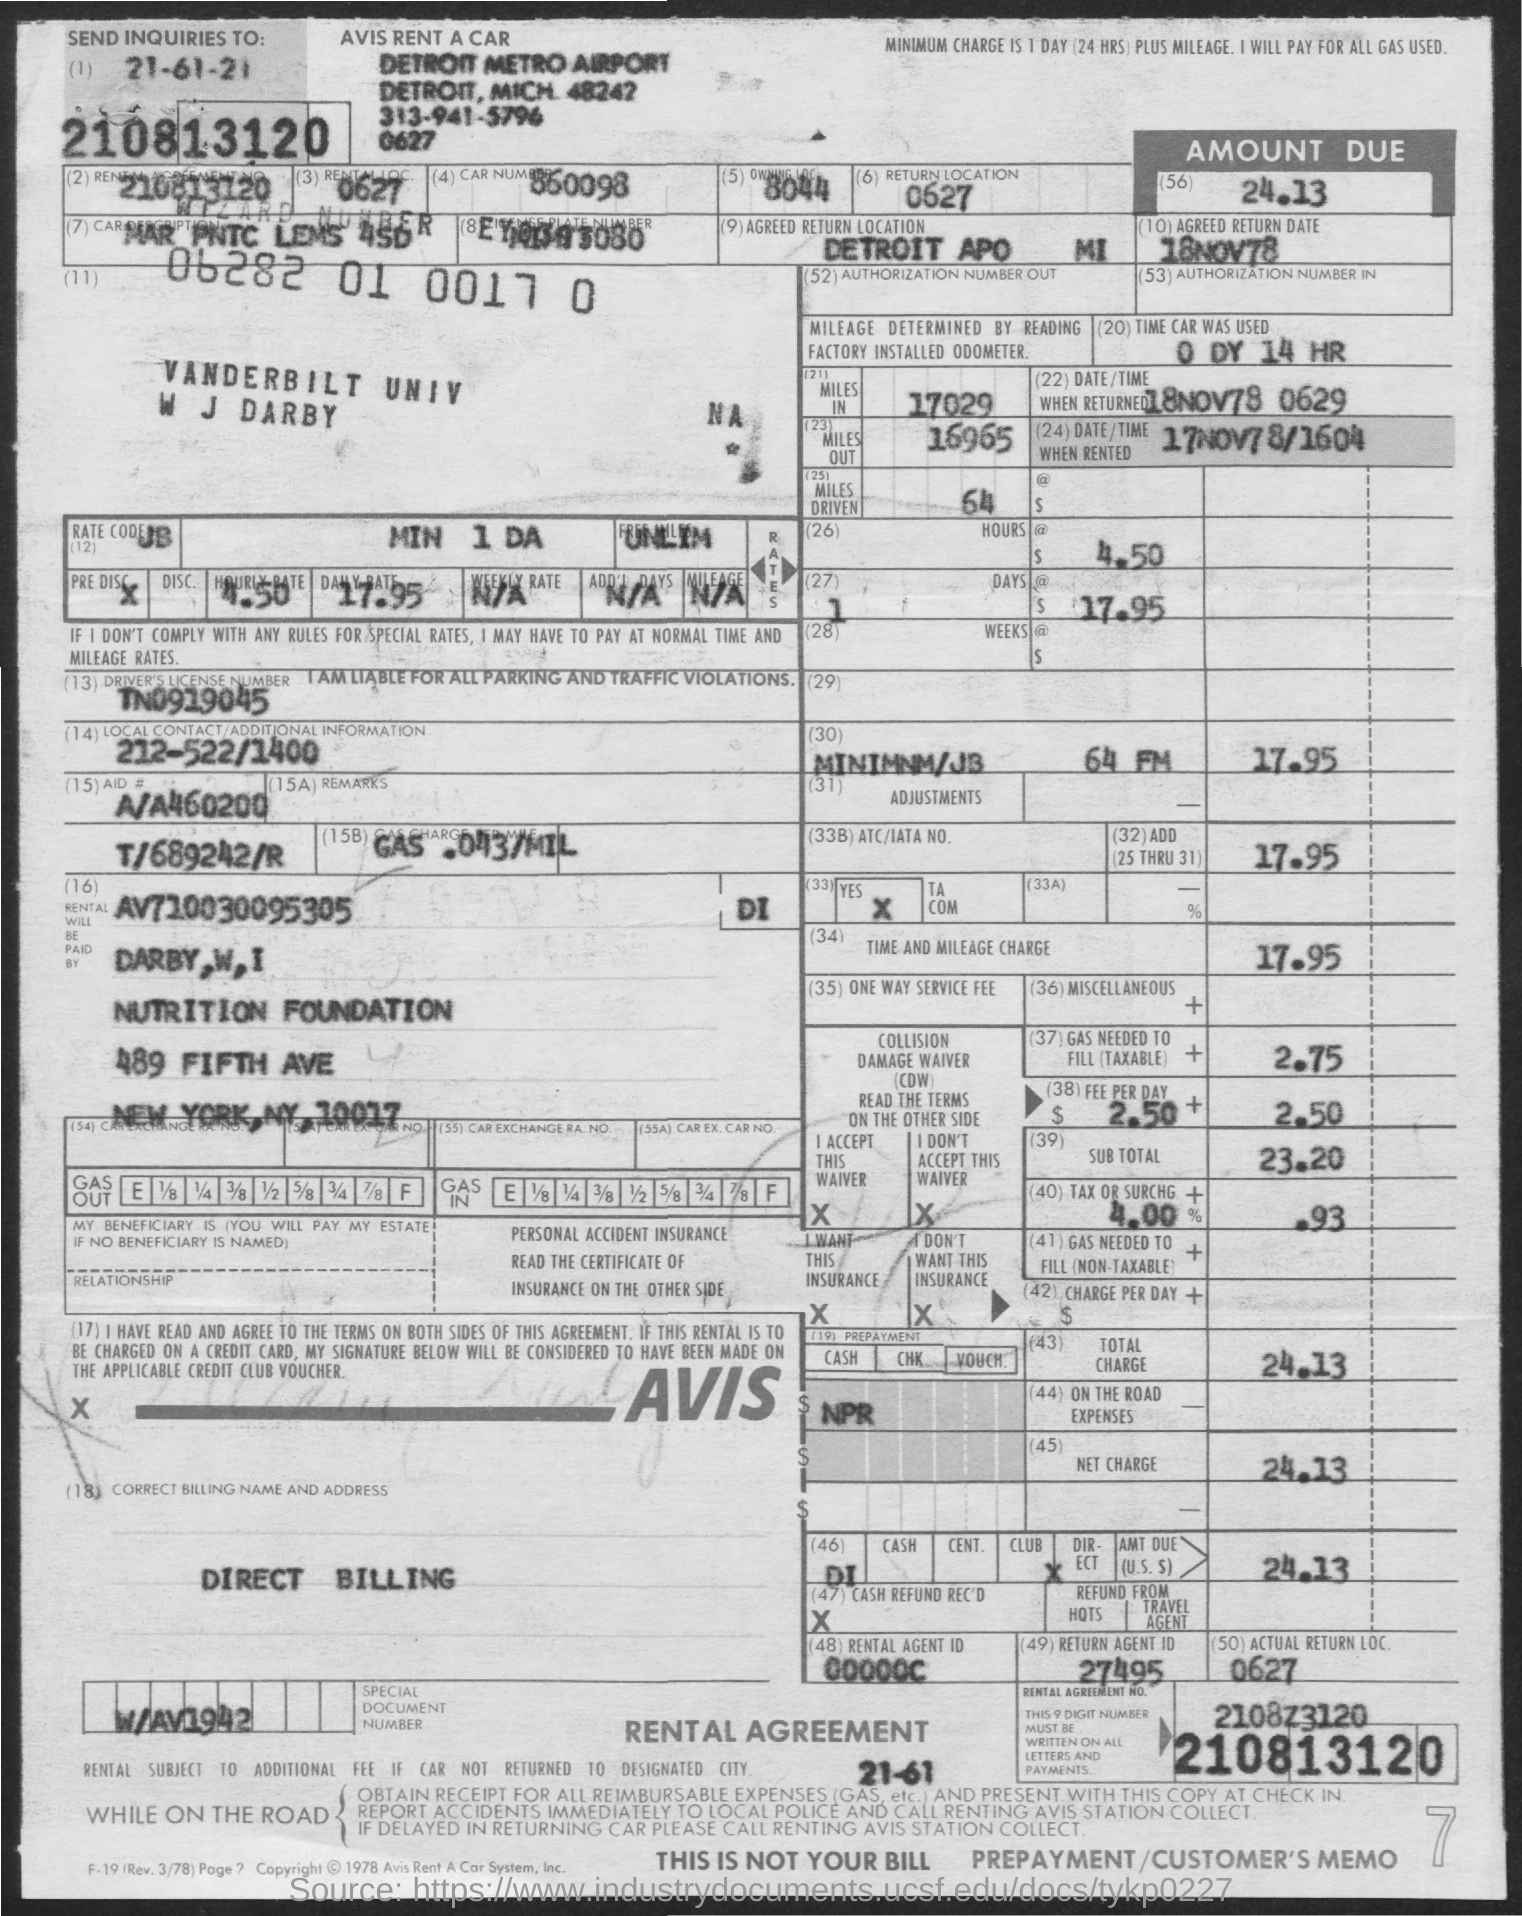What is the car number mentioned in the given form ?
Provide a short and direct response. 860098. What is the number of owning location mentioned in the given form ?
Make the answer very short. 8044. What is the number of return location mentioned in the given form ?
Provide a succinct answer. 0627. What is the number of miles in mentioned in the given form ?
Ensure brevity in your answer.  17029. What is the number of miles out mentioned in the given form ?
Offer a very short reply. 16965. What is the number of miles driven as mentioned in the given form ?
Offer a terse response. 64. How much time the car was used as mentioned in the given form ?
Your response must be concise. 0 DY 14 HR. 